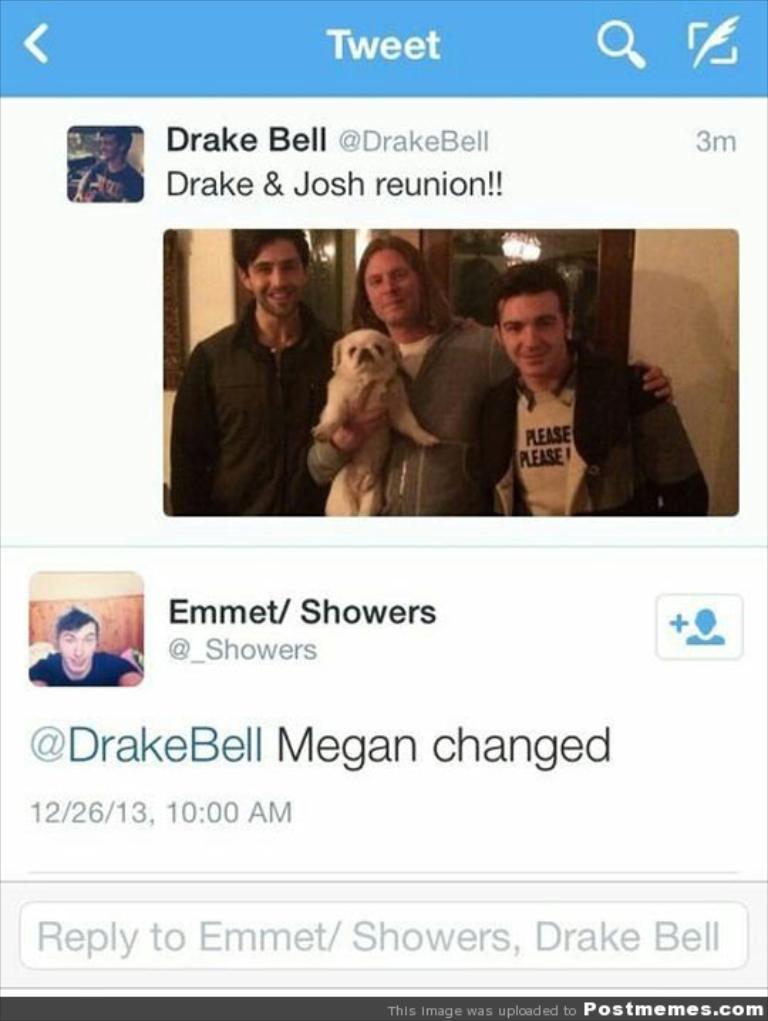Please provide a concise description of this image. In this picture we can see a screen, on which we can see some images and text. 